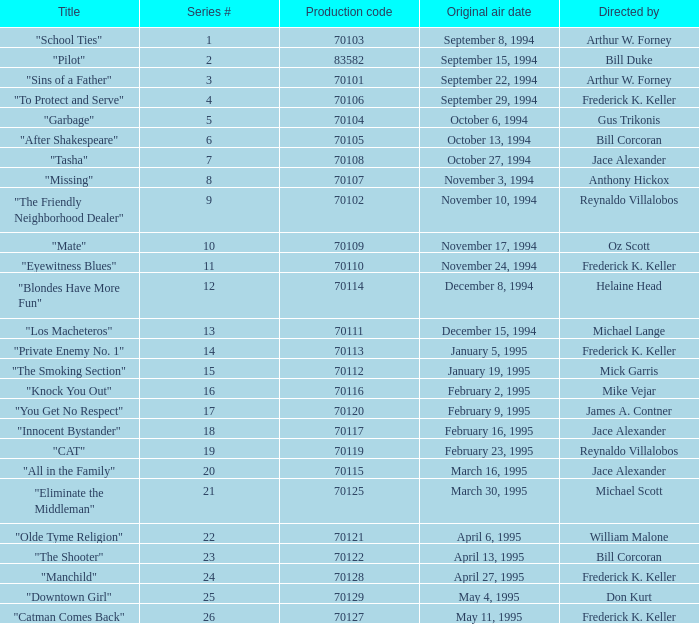For the "Downtown Girl" episode, what was the original air date? May 4, 1995. 